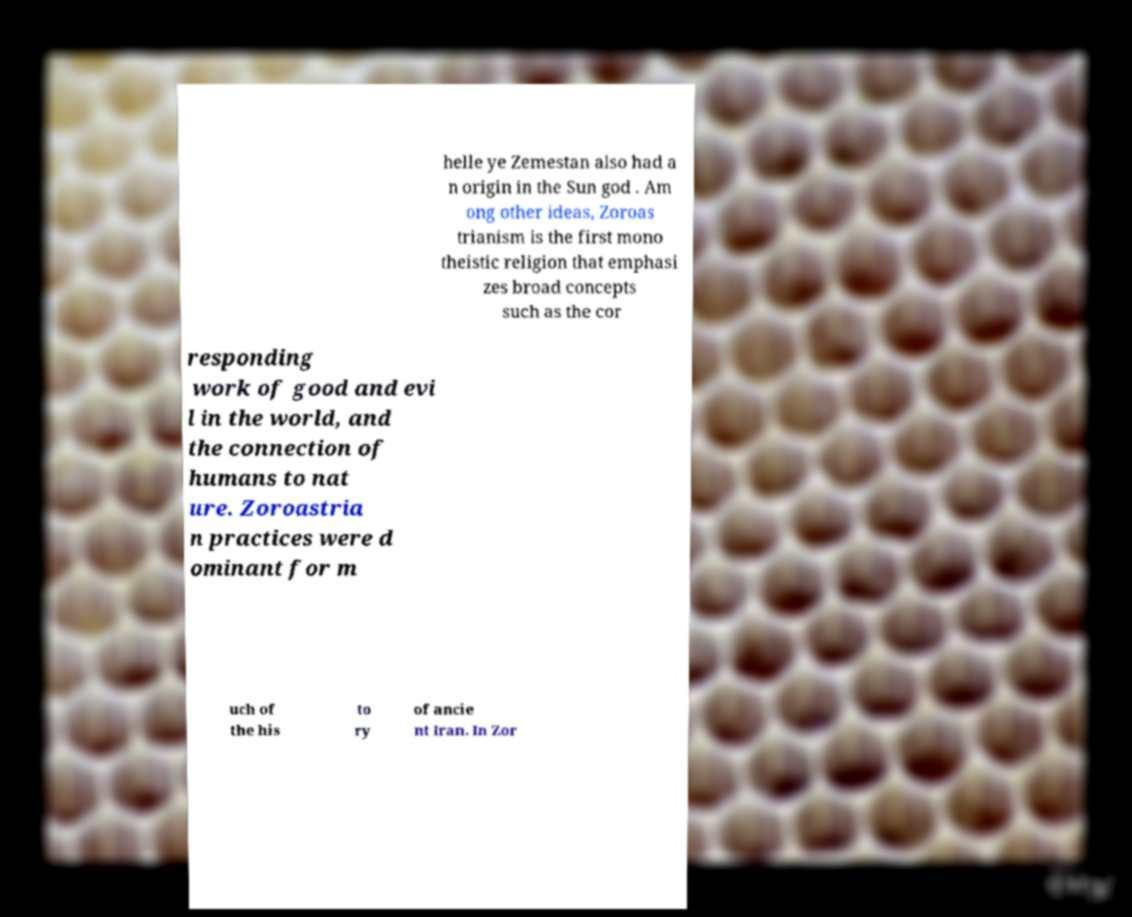There's text embedded in this image that I need extracted. Can you transcribe it verbatim? helle ye Zemestan also had a n origin in the Sun god . Am ong other ideas, Zoroas trianism is the first mono theistic religion that emphasi zes broad concepts such as the cor responding work of good and evi l in the world, and the connection of humans to nat ure. Zoroastria n practices were d ominant for m uch of the his to ry of ancie nt Iran. In Zor 